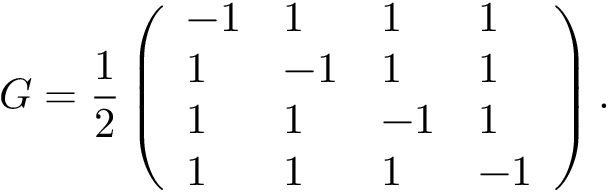Convert formula to latex. <formula><loc_0><loc_0><loc_500><loc_500>G = \frac { 1 } { 2 } \left ( \begin{array} { l l l l } { - 1 } & { 1 } & { 1 } & { 1 } \\ { 1 } & { - 1 } & { 1 } & { 1 } \\ { 1 } & { 1 } & { - 1 } & { 1 } \\ { 1 } & { 1 } & { 1 } & { - 1 } \end{array} \right ) .</formula> 